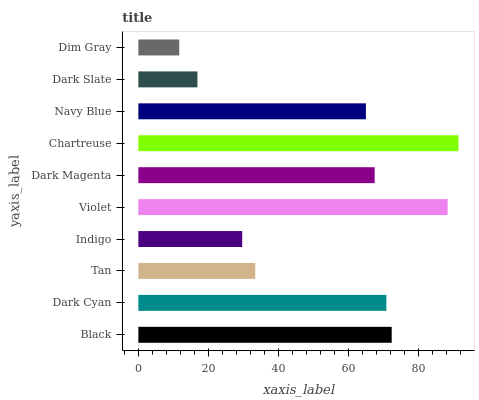Is Dim Gray the minimum?
Answer yes or no. Yes. Is Chartreuse the maximum?
Answer yes or no. Yes. Is Dark Cyan the minimum?
Answer yes or no. No. Is Dark Cyan the maximum?
Answer yes or no. No. Is Black greater than Dark Cyan?
Answer yes or no. Yes. Is Dark Cyan less than Black?
Answer yes or no. Yes. Is Dark Cyan greater than Black?
Answer yes or no. No. Is Black less than Dark Cyan?
Answer yes or no. No. Is Dark Magenta the high median?
Answer yes or no. Yes. Is Navy Blue the low median?
Answer yes or no. Yes. Is Dark Slate the high median?
Answer yes or no. No. Is Tan the low median?
Answer yes or no. No. 